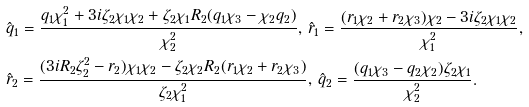<formula> <loc_0><loc_0><loc_500><loc_500>& { \hat { q } } _ { 1 } = \frac { q _ { 1 } \chi _ { 1 } ^ { 2 } + 3 i \zeta _ { 2 } \chi _ { 1 } \chi _ { 2 } + \zeta _ { 2 } \chi _ { 1 } R _ { 2 } ( q _ { 1 } \chi _ { 3 } - \chi _ { 2 } q _ { 2 } ) } { \chi _ { 2 } ^ { 2 } } , \, { \hat { r } } _ { 1 } = \frac { ( r _ { 1 } \chi _ { 2 } + r _ { 2 } \chi _ { 3 } ) \chi _ { 2 } - 3 i \zeta _ { 2 } \chi _ { 1 } \chi _ { 2 } } { \chi _ { 1 } ^ { 2 } } , & \\ & { \hat { r } } _ { 2 } = \frac { ( 3 i R _ { 2 } \zeta _ { 2 } ^ { 2 } - r _ { 2 } ) \chi _ { 1 } \chi _ { 2 } - \zeta _ { 2 } \chi _ { 2 } R _ { 2 } ( r _ { 1 } \chi _ { 2 } + r _ { 2 } \chi _ { 3 } ) } { \zeta _ { 2 } \chi _ { 1 } ^ { 2 } } , \, { \hat { q } } _ { 2 } = \frac { ( q _ { 1 } \chi _ { 3 } - q _ { 2 } \chi _ { 2 } ) \zeta _ { 2 } \chi _ { 1 } } { \chi _ { 2 } ^ { 2 } } . &</formula> 